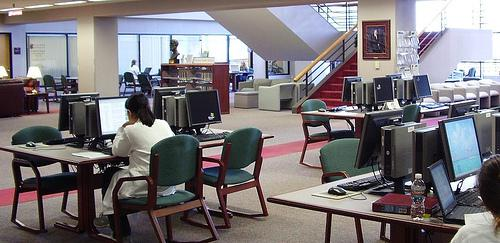Question: who is sitting to the left?
Choices:
A. A man.
B. A child.
C. A lady.
D. A young woman.
Answer with the letter. Answer: C 